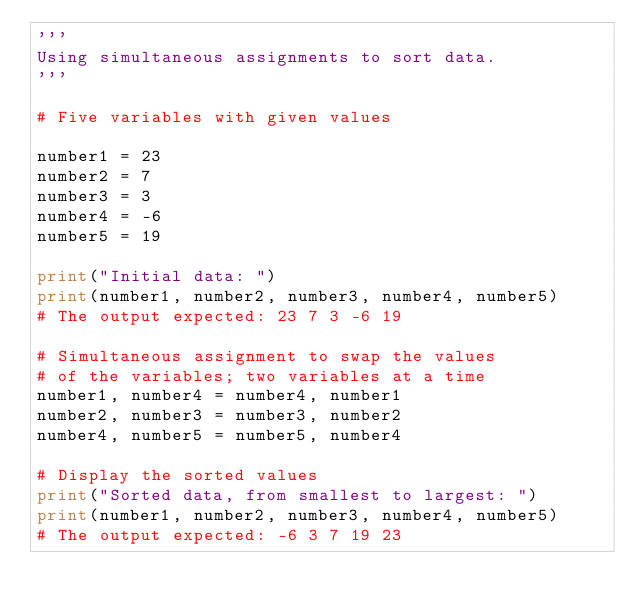Convert code to text. <code><loc_0><loc_0><loc_500><loc_500><_Python_>'''
Using simultaneous assignments to sort data.
'''

# Five variables with given values

number1 = 23
number2 = 7
number3 = 3
number4 = -6
number5 = 19

print("Initial data: ")
print(number1, number2, number3, number4, number5)
# The output expected: 23 7 3 -6 19

# Simultaneous assignment to swap the values
# of the variables; two variables at a time
number1, number4 = number4, number1
number2, number3 = number3, number2
number4, number5 = number5, number4

# Display the sorted values
print("Sorted data, from smallest to largest: ")
print(number1, number2, number3, number4, number5)
# The output expected: -6 3 7 19 23
</code> 